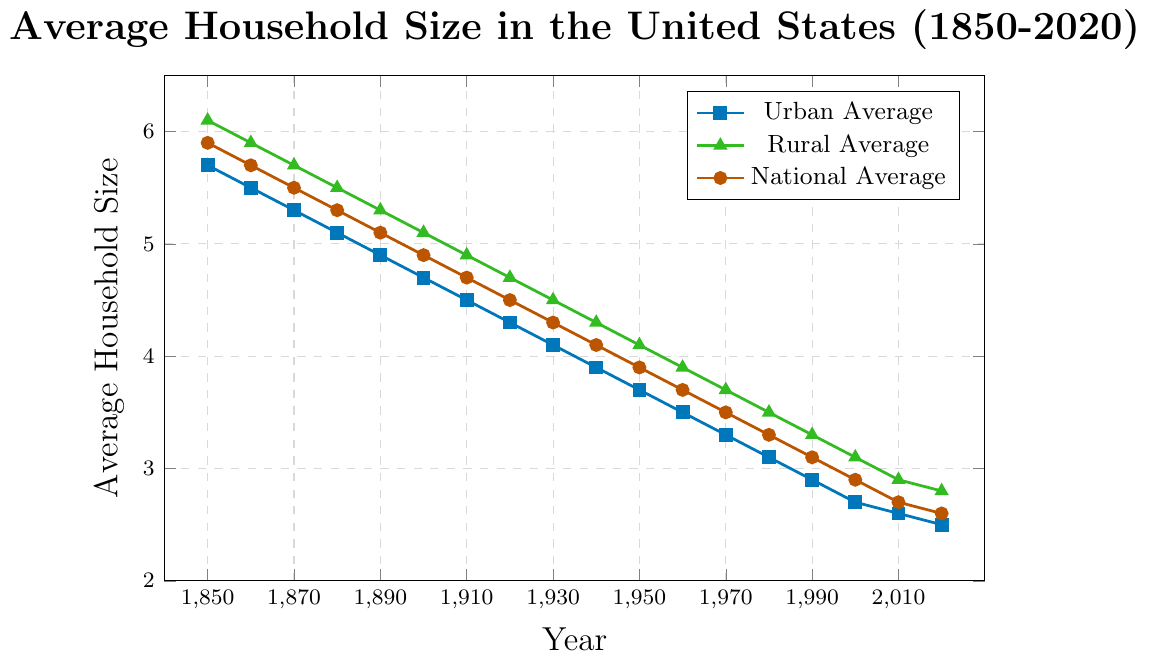What was the average household size in rural areas in 1900? Look at the data point labeled for rural areas in 1900 along the green line. This is the value you need.
Answer: 5.1 How much did the national average household size decrease from 1850 to 2020? Find the national average for 1850 (5.9) and for 2020 (2.6). Subtract the latter from the former: 5.9 - 2.6 = 3.3.
Answer: 3.3 During which decade did the urban average household size first drop below 4? Trace the blue line representing urban areas and identify the year when it first drops below 4. This occurs between 1930 and 1940.
Answer: 1940 Compare the difference between the rural and urban average household sizes in 1920 and in 2020. Which gap is larger and by how much? In 1920, the rural average is 4.7 and the urban average is 4.3, so the difference is 4.7 - 4.3 = 0.4. In 2020, the rural average is 2.8 and the urban average is 2.5, so the difference is 2.8 - 2.5 = 0.3. The gap in 1920 is larger. The difference between 0.4 and 0.3 is 0.1.
Answer: 1920, 0.1 What trend can you observe about the average household size in rural areas from 1850 to 2020? Observe the green line and note that it starts high in 1850 and consistently decreases until 2020. This indicates a downward trend in the average household size in rural areas over time.
Answer: Downward trend Find the year when the national average household size was 4.5. Look along the national average line (brown) and find the year corresponding to the value 4.5. This occurs around 1920.
Answer: 1920 In which decade did the overall national average household size become less than the rural average? Compare the brown and green lines to determine the decade when the brown line first falls below the green one. This happens between 1910 and 1920.
Answer: 1920 Which has shown a steeper decline rate, urban or rural average household size, between 1850 and 2020? Compare the slopes of the blue and green lines from 1850 to 2020. The urban average shows a steeper decline as it began at 5.7 and ended at 2.5, compared to the rural average which started at 6.1 and ended at 2.8.
Answer: Urban By how much did the rural average household size decrease from 1950 to 2020, and how does this decrease compare to the urban average over the same period? Calculate the difference for both rural and urban lines from 1950 to 2020. Rural: 4.1 - 2.8 = 1.3. Urban: 3.7 - 2.5 = 1.2. The rural decrease is 1.3, which is slightly higher than the urban decrease of 1.2.
Answer: Rural: 1.3, Urban: 1.2 What year did the urban and rural averages converge to the same value? Find the point where the blue and green lines intersect. This convergence happens around 1960.
Answer: 1960 